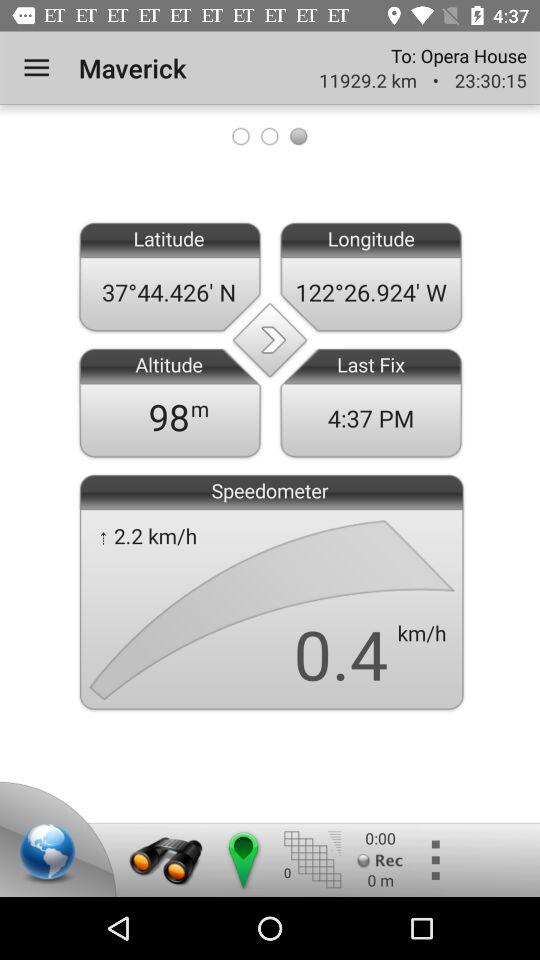How many kilometers is the distance between the Maverick and the Opera House?
Answer the question using a single word or phrase. 11929.2 